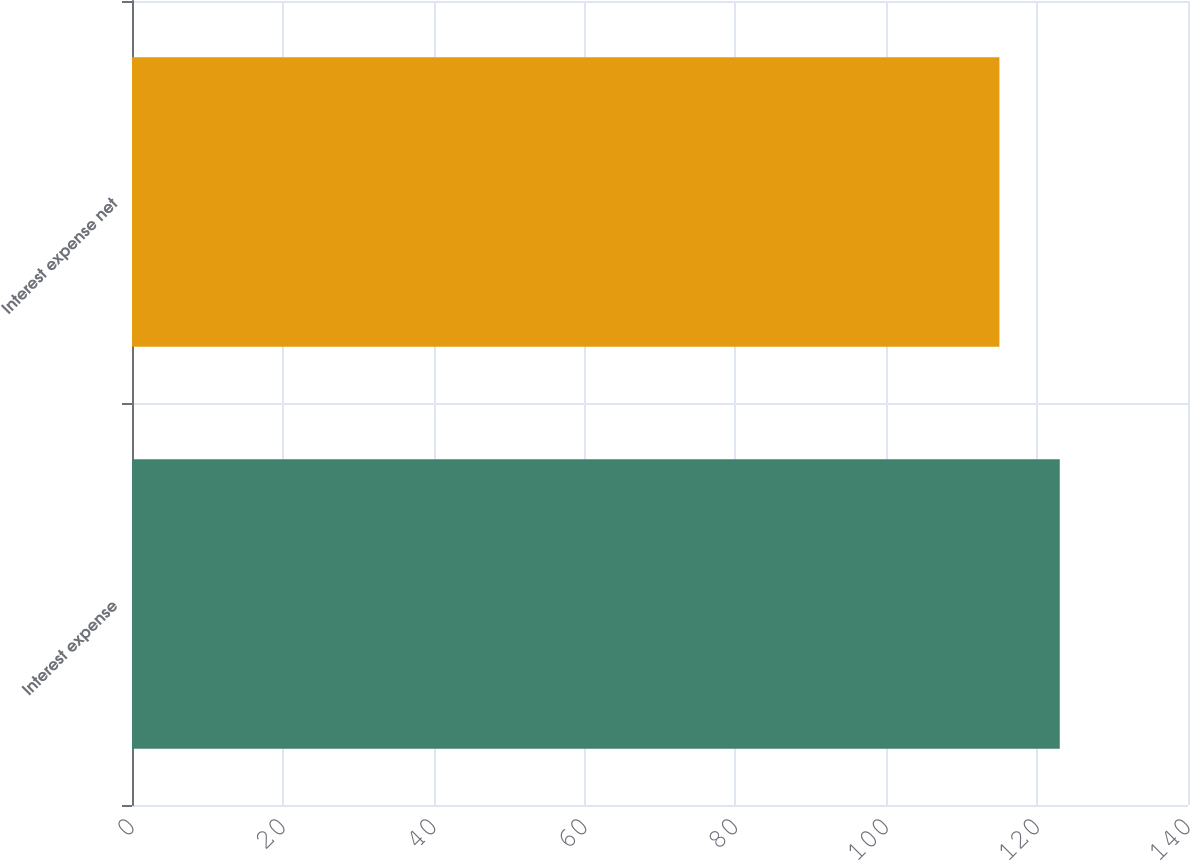Convert chart to OTSL. <chart><loc_0><loc_0><loc_500><loc_500><bar_chart><fcel>Interest expense<fcel>Interest expense net<nl><fcel>123<fcel>115<nl></chart> 